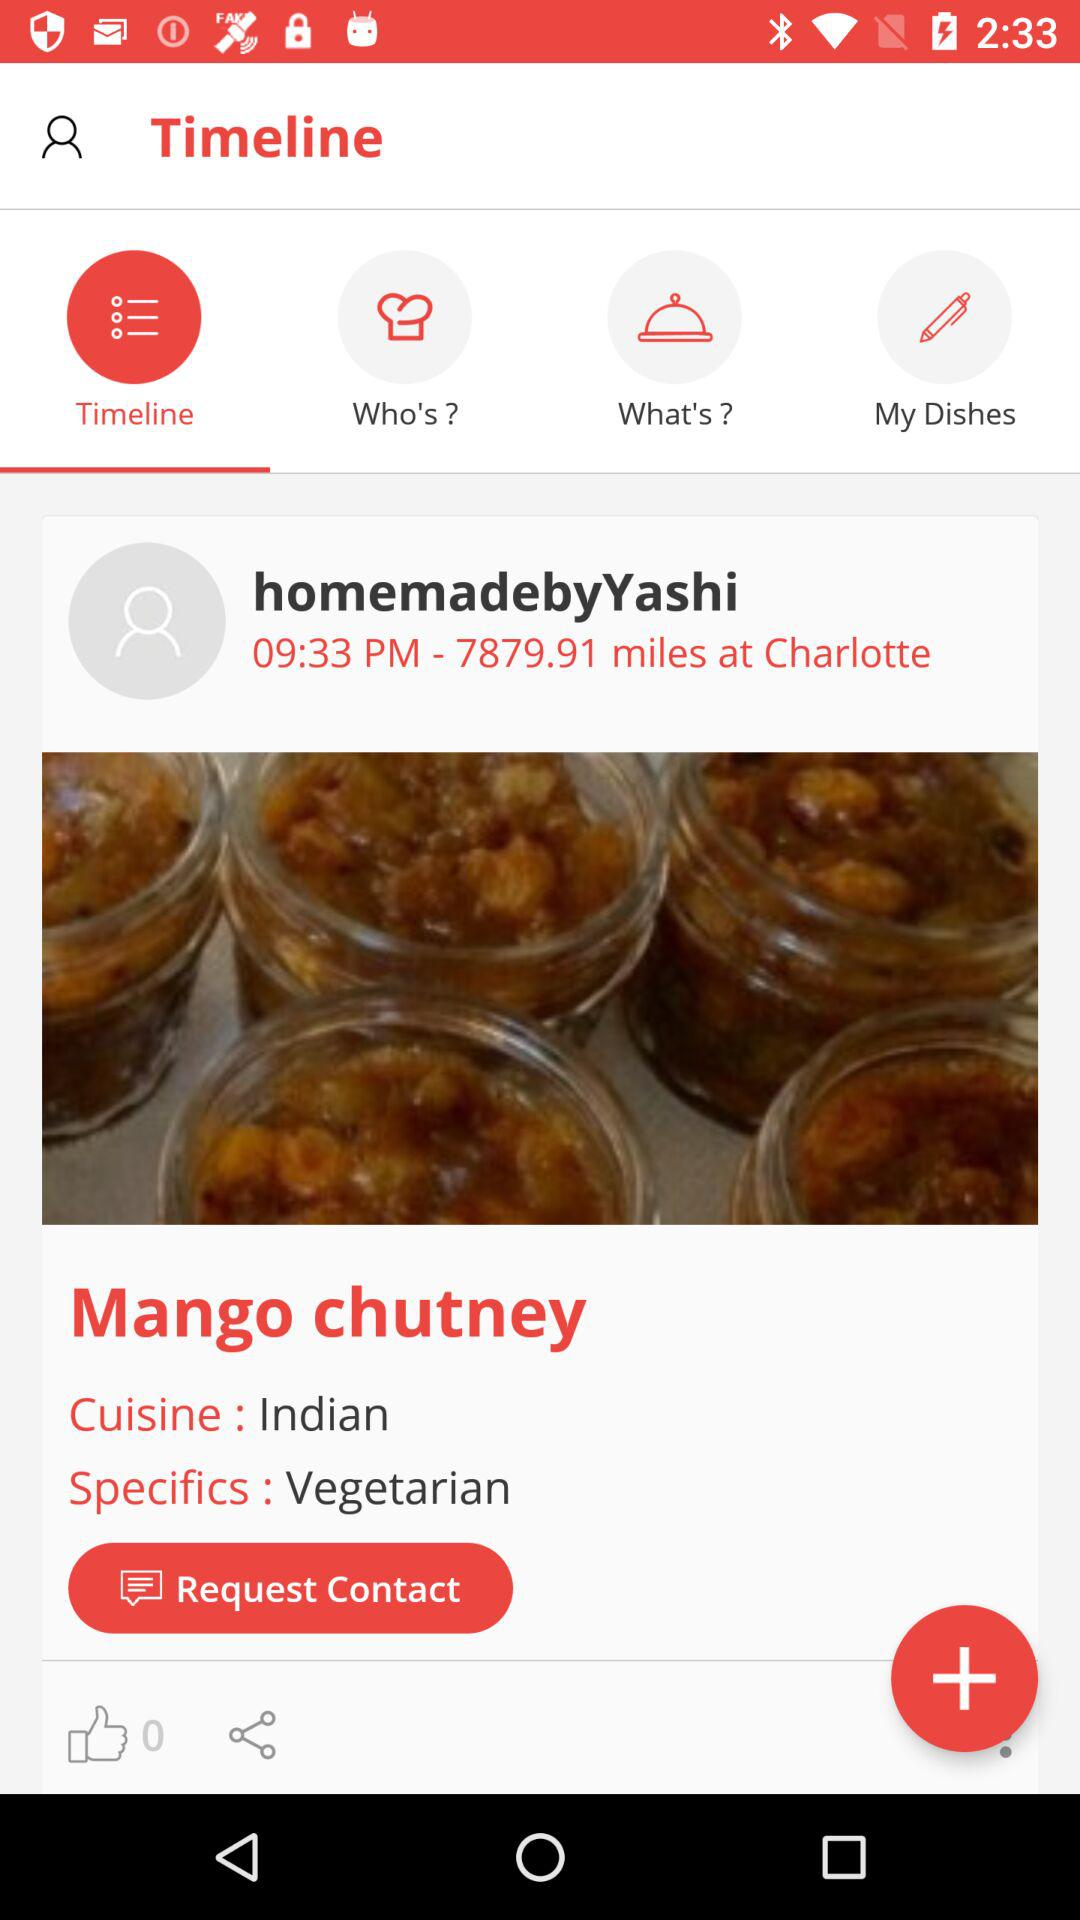What is the name of the dish? The name of the dish is "Mango chutney". 